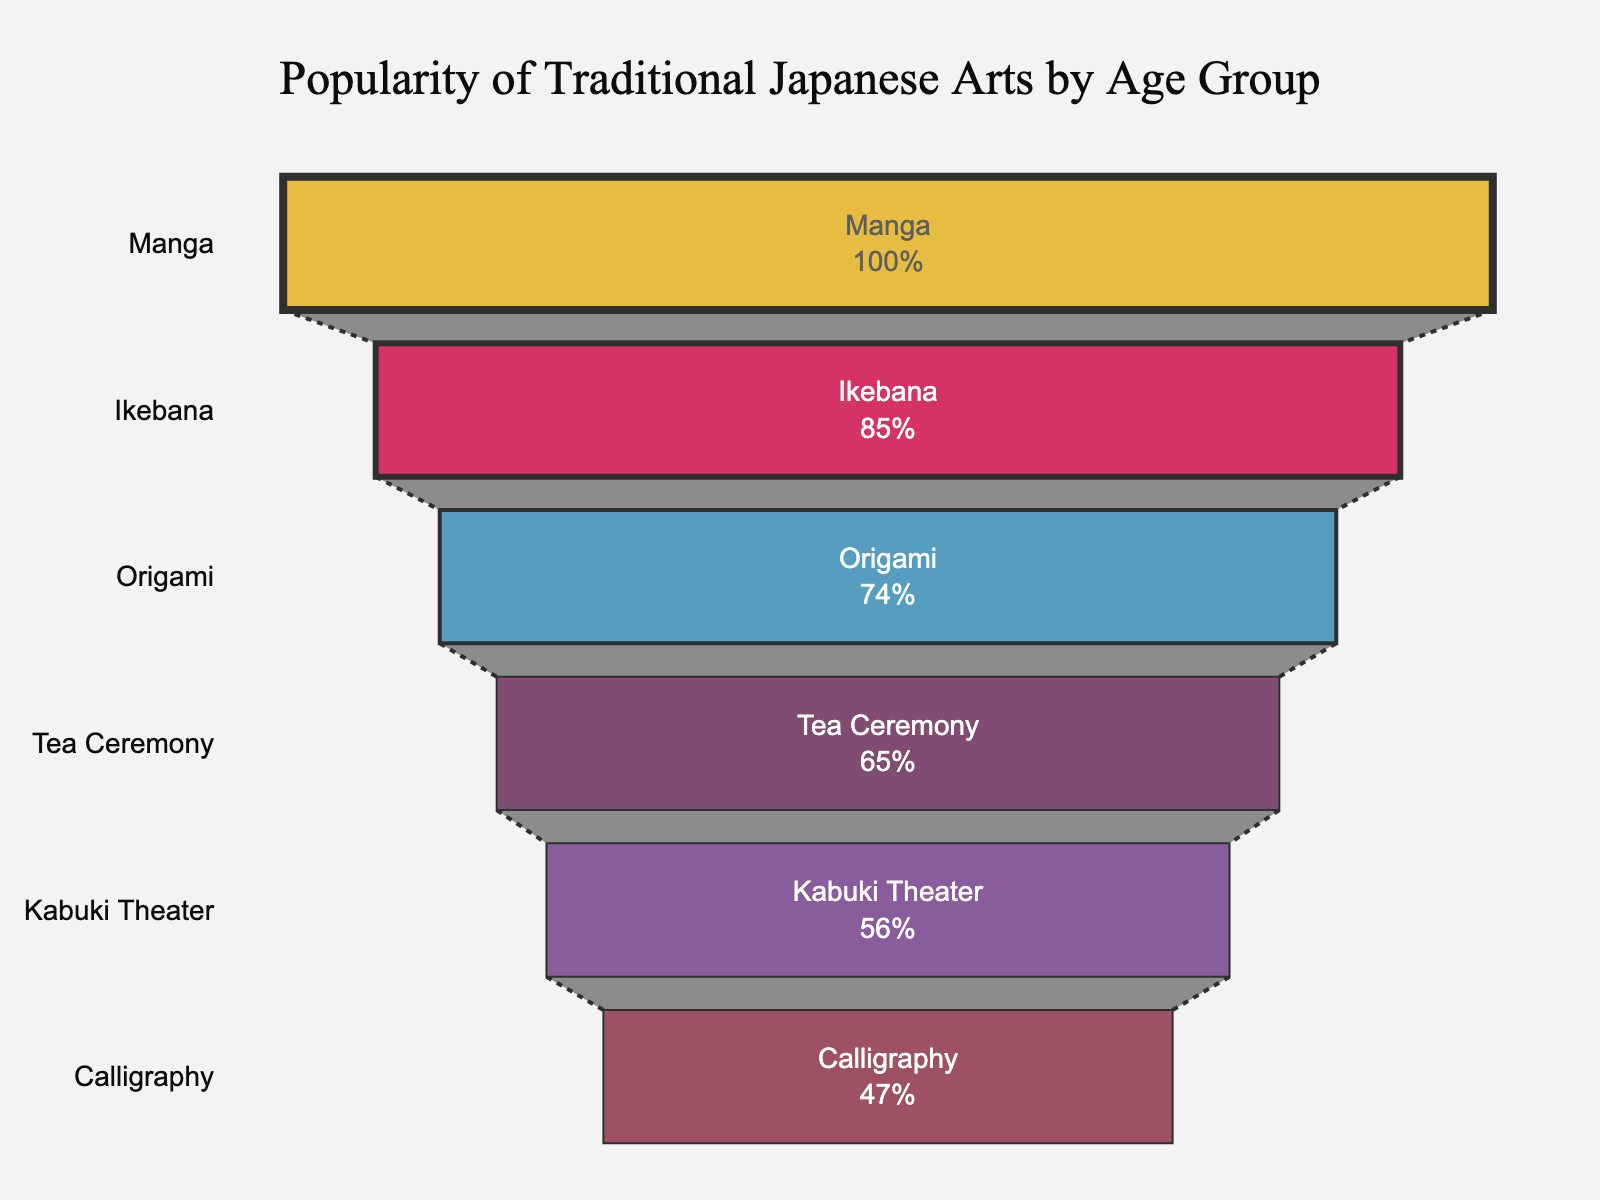what is the most popular traditional Japanese art among the youngest age group? The funnel chart displays the traditional Japanese art forms and their popularity percentages by age group. The art form with the highest popularity percentage in the given data is Manga, which is associated with the 18-24 age group.
Answer: Manga What's the least popular traditional Japanese art among aged 65+? The funnel chart shows different art forms with their popularity percentages for various age groups. The least popular art form for the age group 65+ is Calligraphy, with a popularity percentage of 40%.
Answer: Calligraphy Which traditional Japanese art is preferred by the age group 35-44? The funnel chart indicates the popularity of different traditional Japanese arts by age group. For the age group 35-44, Origami has a popularity percentage of 63%.
Answer: Origami How much more popular is Manga among the 18-24 age group compared to Kabuki Theater among the 55-64 age group? The funnel chart shows that Manga has a popularity percentage of 85% for the 18-24 age group, while Kabuki Theater has 48% for the 55-64 age group. The difference is 85% - 48% = 37%.
Answer: 37% Which age group shows the highest percentage preference for Traditonal Japanese Art? The funnel chart compares the popularity percentages of traditional Japanese arts among different age groups. The age group 18-24 shows the highest preference with 85% for Manga.
Answer: 18-24 What's the sum of popularity percentages for Calligraphy among those aged 65+ and for Tea Ceremony among those aged 45-54? The funnel chart shows Calligraphy has a popularity percentage of 40% among the 65+ age group, and Tea Ceremony has 55% among the 45-54 age group. The sum is 40% + 55% = 95%.
Answer: 95% Which traditional Japanese art is more popular: Ikebana among 25-34 or Kabuki Theater among 55-64? The funnel chart indicates that Ikebana has a popularity percentage of 72% for the 25-34 age group, whereas Kabuki Theater has 48% for the 55-64 age group. Ikebana is more popular.
Answer: Ikebana What is the average popularity percentage of all traditional Japanese arts listed? To find the average popularity percentage, sum all the percentages: 85% (Manga) + 72% (Ikebana) + 63% (Origami) + 55% (Tea Ceremony) + 48% (Kabuki Theater) + 40% (Calligraphy) = 363%. Then divide by the number of age groups, which is 6. The average is 363% / 6 = 60.5%.
Answer: 60.5% How many traditional Japanese arts have a popularity percentage above 50%? The funnel chart displays six traditional Japanese arts. Those with popularity percentages above 50% are Manga (85%), Ikebana (72%), Origami (63%), and Tea Ceremony (55%). There are 4 such arts.
Answer: 4 What is the percentage difference between the most popular and the least popular traditional Japanese arts among all age groups? The funnel chart shows the percentage for the most popular art (Manga) as 85% and for the least popular (Calligraphy) as 40%. The difference is 85% - 40% = 45%.
Answer: 45% 